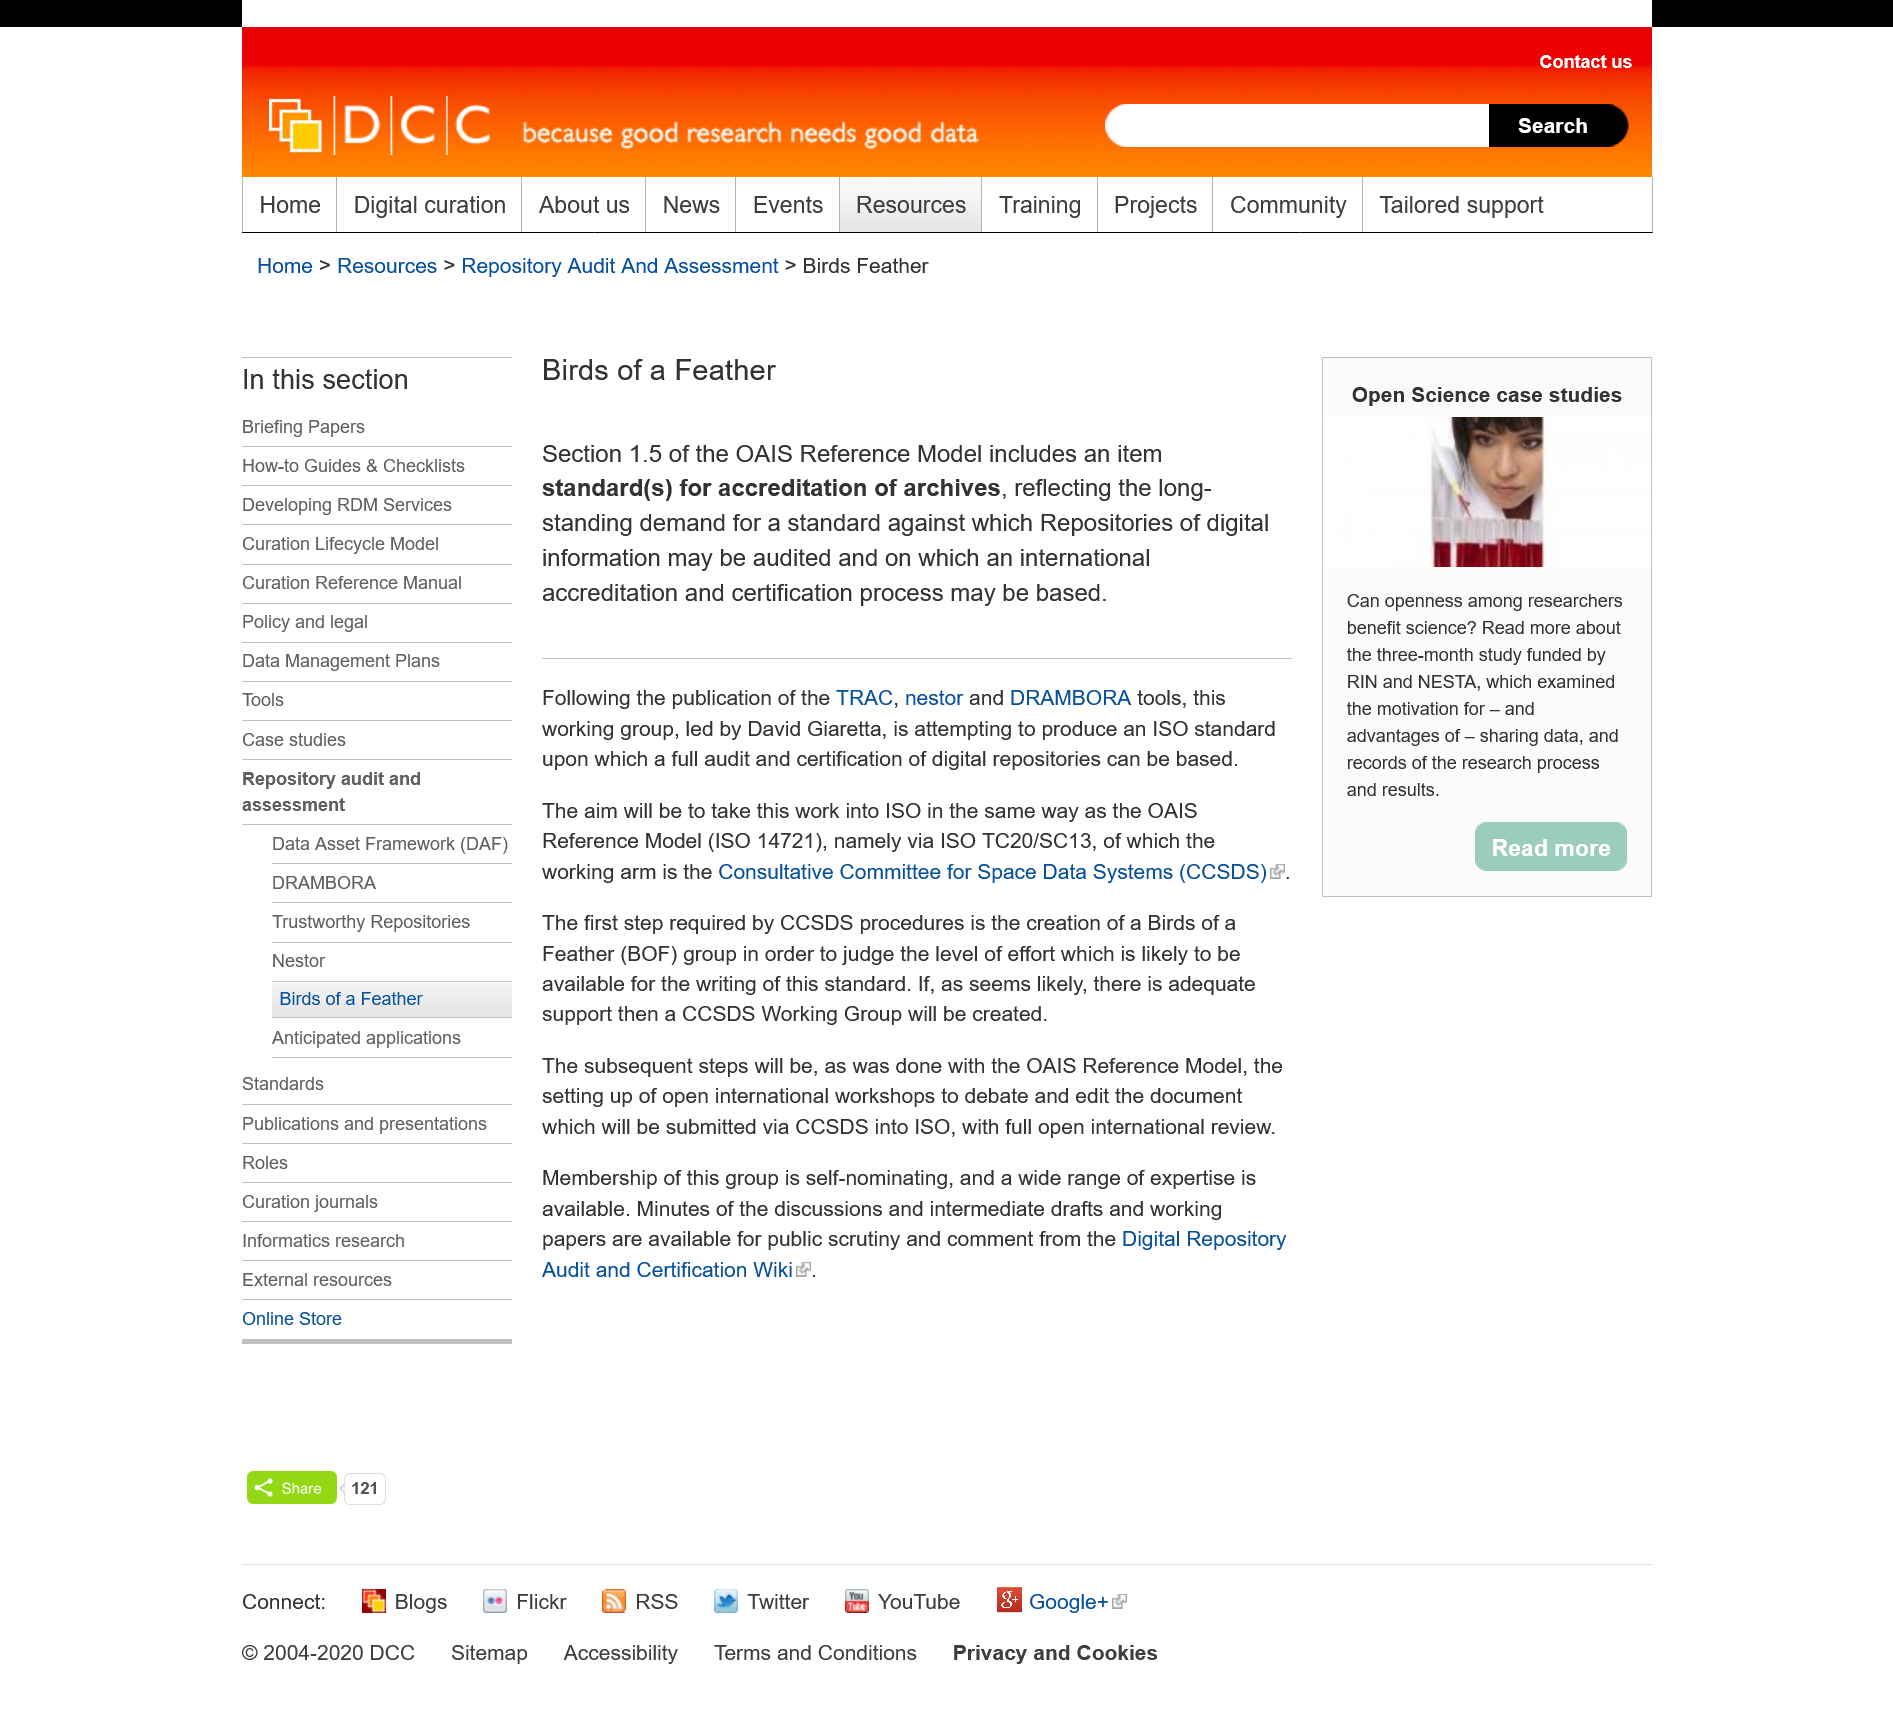Point out several critical features in this image. Accreditation standards for archives are available in section 1.5 of the Open Archival Information System Reference Model. The aim of the group is to achieve the goal of incorporating the OAIS Reference Model into the ISO standard for digital preservation, in the same manner as the OAIS Reference Model has been successfully implemented. The leader of the workgroup is David Giaretta. 